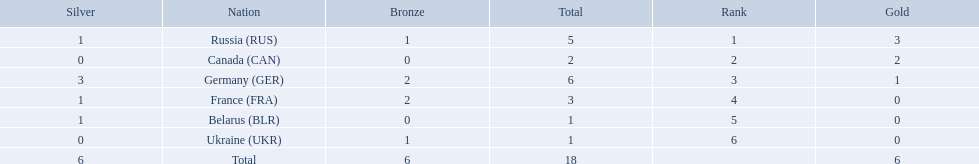What were all the countries that won biathlon medals? Russia (RUS), Canada (CAN), Germany (GER), France (FRA), Belarus (BLR), Ukraine (UKR). What were their medal counts? 5, 2, 6, 3, 1, 1. Of these, which is the largest number of medals? 6. Which country won this number of medals? Germany (GER). 